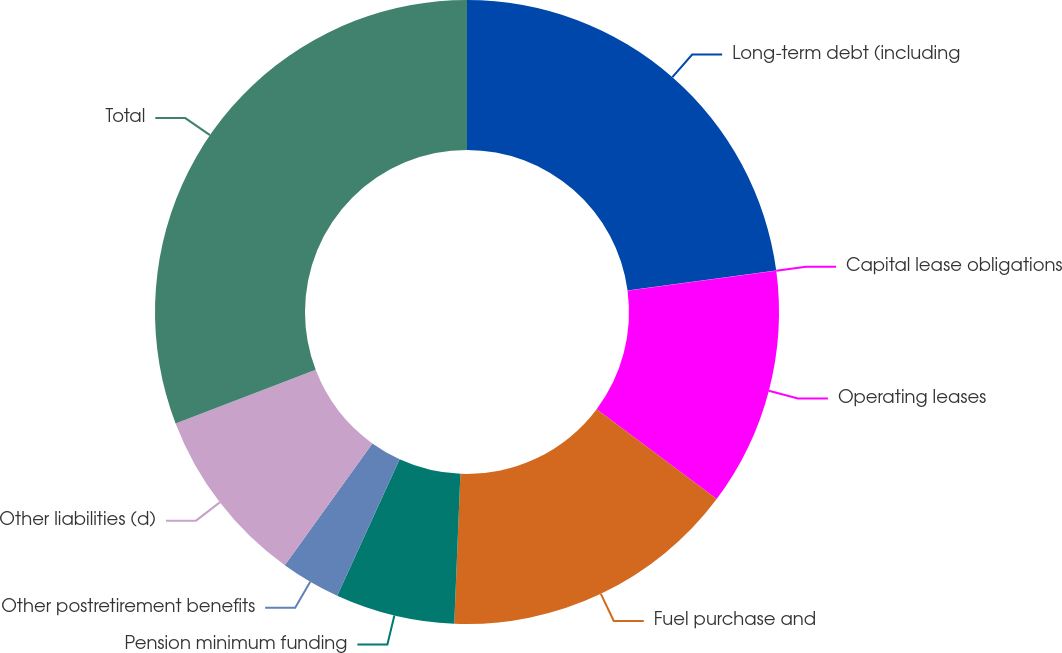<chart> <loc_0><loc_0><loc_500><loc_500><pie_chart><fcel>Long-term debt (including<fcel>Capital lease obligations<fcel>Operating leases<fcel>Fuel purchase and<fcel>Pension minimum funding<fcel>Other postretirement benefits<fcel>Other liabilities (d)<fcel>Total<nl><fcel>22.88%<fcel>0.02%<fcel>12.34%<fcel>15.42%<fcel>6.18%<fcel>3.1%<fcel>9.26%<fcel>30.82%<nl></chart> 